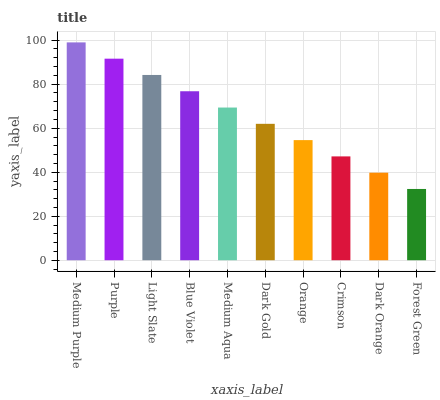Is Purple the minimum?
Answer yes or no. No. Is Purple the maximum?
Answer yes or no. No. Is Medium Purple greater than Purple?
Answer yes or no. Yes. Is Purple less than Medium Purple?
Answer yes or no. Yes. Is Purple greater than Medium Purple?
Answer yes or no. No. Is Medium Purple less than Purple?
Answer yes or no. No. Is Medium Aqua the high median?
Answer yes or no. Yes. Is Dark Gold the low median?
Answer yes or no. Yes. Is Forest Green the high median?
Answer yes or no. No. Is Medium Aqua the low median?
Answer yes or no. No. 